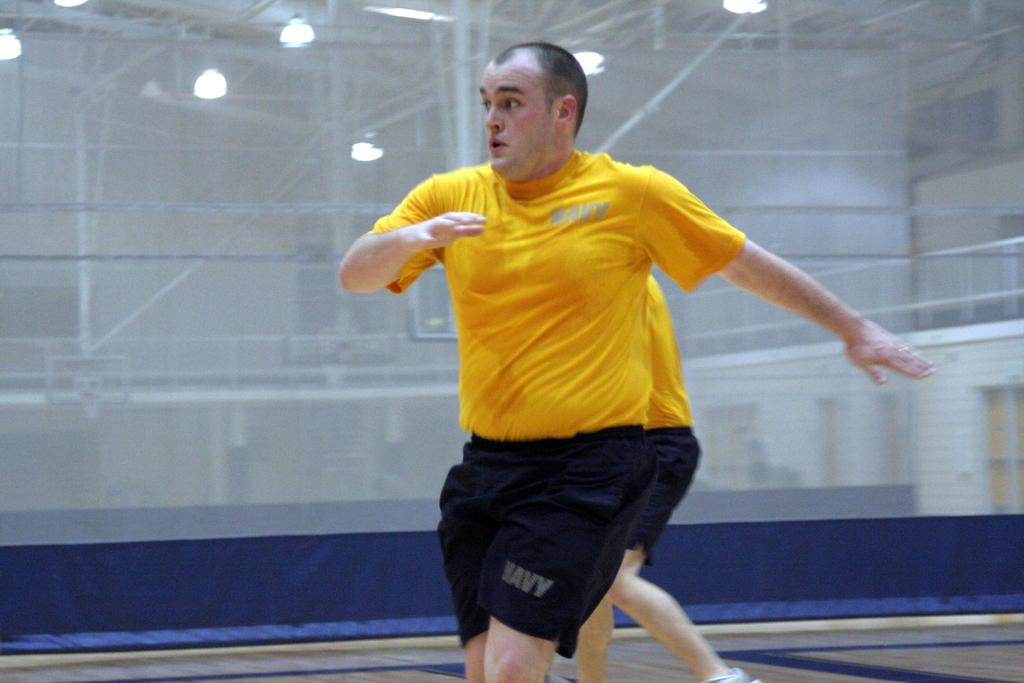How many people are in the image? There are two persons in the middle of the image. What can be seen in the background of the image? There is a curtain in the background of the image. What is visible through the curtain? Lights and poles are visible through the curtain. Is there a mailbox visible in the image? No, there is no mailbox present in the image. Are there any cobwebs visible in the image? No, there are no cobwebs visible in the image. 